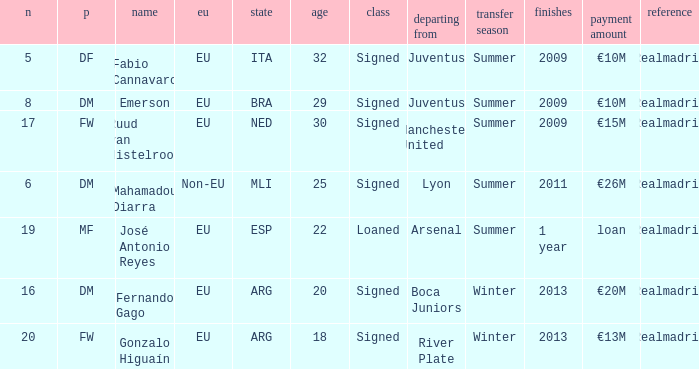What is the EU status of ESP? EU. Give me the full table as a dictionary. {'header': ['n', 'p', 'name', 'eu', 'state', 'age', 'class', 'departing from', 'transfer season', 'finishes', 'payment amount', 'reference'], 'rows': [['5', 'DF', 'Fabio Cannavaro', 'EU', 'ITA', '32', 'Signed', 'Juventus', 'Summer', '2009', '€10M', 'Realmadrid'], ['8', 'DM', 'Emerson', 'EU', 'BRA', '29', 'Signed', 'Juventus', 'Summer', '2009', '€10M', 'Realmadrid'], ['17', 'FW', 'Ruud van Nistelrooy', 'EU', 'NED', '30', 'Signed', 'Manchester United', 'Summer', '2009', '€15M', 'Realmadrid'], ['6', 'DM', 'Mahamadou Diarra', 'Non-EU', 'MLI', '25', 'Signed', 'Lyon', 'Summer', '2011', '€26M', 'Realmadrid'], ['19', 'MF', 'José Antonio Reyes', 'EU', 'ESP', '22', 'Loaned', 'Arsenal', 'Summer', '1 year', 'loan', 'Realmadrid'], ['16', 'DM', 'Fernando Gago', 'EU', 'ARG', '20', 'Signed', 'Boca Juniors', 'Winter', '2013', '€20M', 'Realmadrid'], ['20', 'FW', 'Gonzalo Higuaín', 'EU', 'ARG', '18', 'Signed', 'River Plate', 'Winter', '2013', '€13M', 'Realmadrid']]} 